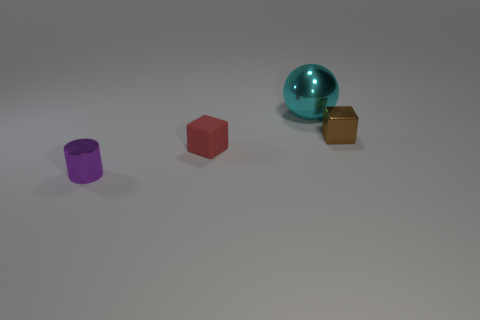Does the metallic cylinder have the same size as the ball?
Your answer should be compact. No. There is a block that is left of the metallic ball; does it have the same size as the large cyan sphere?
Make the answer very short. No. What is the color of the object that is behind the tiny brown metallic block?
Offer a very short reply. Cyan. What number of tiny rubber cubes are there?
Make the answer very short. 1. What shape is the brown object that is the same material as the sphere?
Offer a very short reply. Cube. Do the small cube in front of the small metallic block and the tiny metal thing that is to the right of the tiny cylinder have the same color?
Provide a short and direct response. No. Are there an equal number of red rubber blocks that are right of the large cyan thing and big red blocks?
Provide a succinct answer. Yes. What number of tiny metallic things are in front of the large cyan ball?
Give a very brief answer. 2. How big is the purple object?
Provide a succinct answer. Small. What color is the ball that is the same material as the brown block?
Your response must be concise. Cyan. 